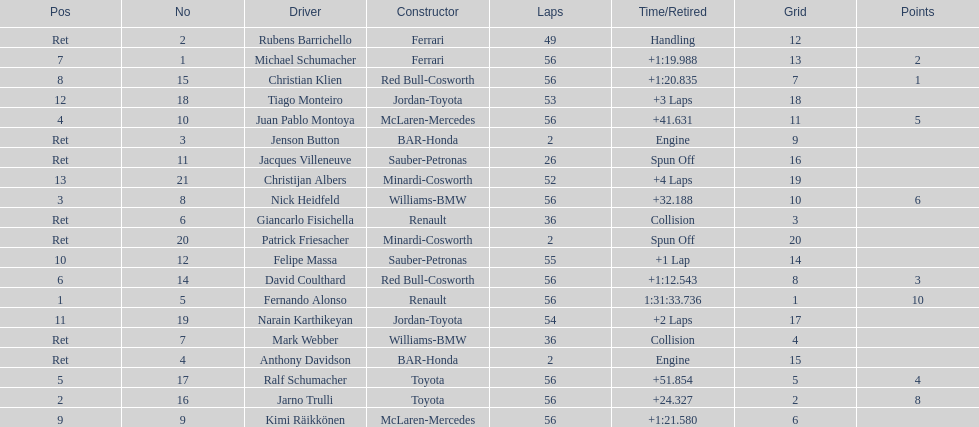For the competitor who secured the 1st position, what was their completed lap count? 56. 